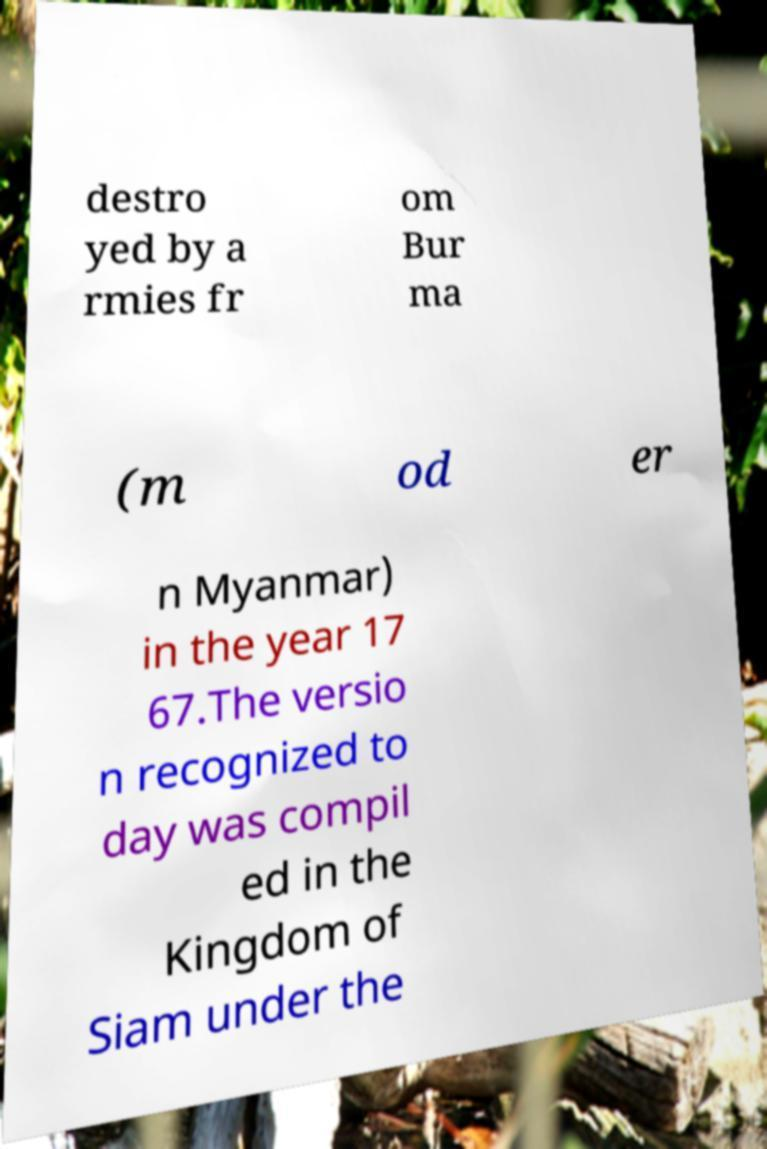For documentation purposes, I need the text within this image transcribed. Could you provide that? destro yed by a rmies fr om Bur ma (m od er n Myanmar) in the year 17 67.The versio n recognized to day was compil ed in the Kingdom of Siam under the 